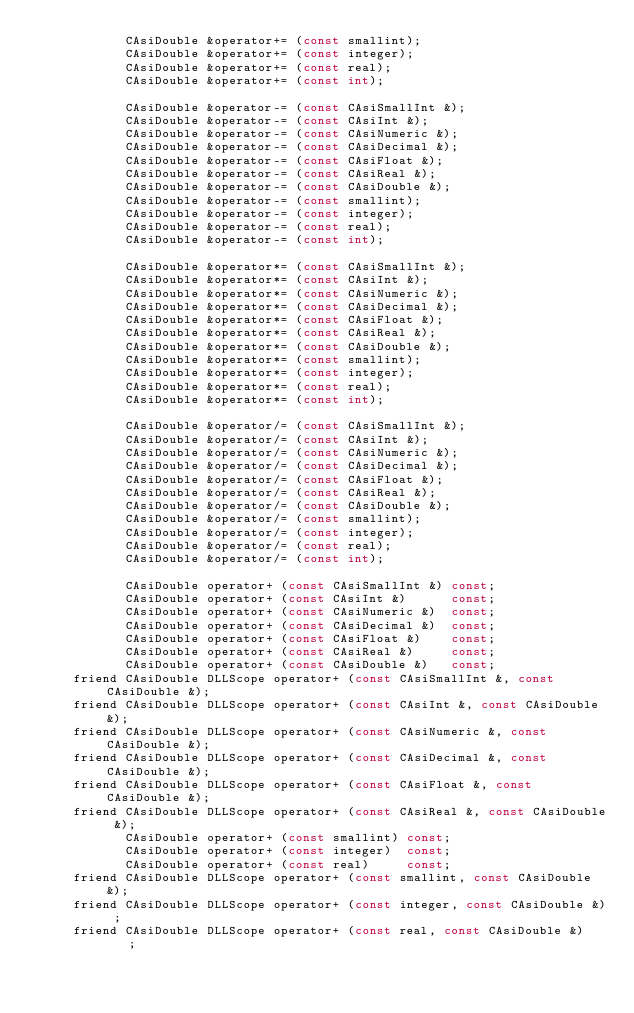Convert code to text. <code><loc_0><loc_0><loc_500><loc_500><_C_>            CAsiDouble &operator+= (const smallint);
            CAsiDouble &operator+= (const integer);
            CAsiDouble &operator+= (const real);
            CAsiDouble &operator+= (const int);

            CAsiDouble &operator-= (const CAsiSmallInt &);
            CAsiDouble &operator-= (const CAsiInt &);
            CAsiDouble &operator-= (const CAsiNumeric &);
            CAsiDouble &operator-= (const CAsiDecimal &);
            CAsiDouble &operator-= (const CAsiFloat &);
            CAsiDouble &operator-= (const CAsiReal &);
            CAsiDouble &operator-= (const CAsiDouble &);
            CAsiDouble &operator-= (const smallint);
            CAsiDouble &operator-= (const integer);
            CAsiDouble &operator-= (const real);
            CAsiDouble &operator-= (const int);

            CAsiDouble &operator*= (const CAsiSmallInt &);
            CAsiDouble &operator*= (const CAsiInt &);
            CAsiDouble &operator*= (const CAsiNumeric &);
            CAsiDouble &operator*= (const CAsiDecimal &);
            CAsiDouble &operator*= (const CAsiFloat &);
            CAsiDouble &operator*= (const CAsiReal &);
            CAsiDouble &operator*= (const CAsiDouble &);
            CAsiDouble &operator*= (const smallint);
            CAsiDouble &operator*= (const integer);
            CAsiDouble &operator*= (const real);
            CAsiDouble &operator*= (const int);

            CAsiDouble &operator/= (const CAsiSmallInt &);
            CAsiDouble &operator/= (const CAsiInt &);
            CAsiDouble &operator/= (const CAsiNumeric &);
            CAsiDouble &operator/= (const CAsiDecimal &);
            CAsiDouble &operator/= (const CAsiFloat &);
            CAsiDouble &operator/= (const CAsiReal &);
            CAsiDouble &operator/= (const CAsiDouble &);
            CAsiDouble &operator/= (const smallint);
            CAsiDouble &operator/= (const integer);
            CAsiDouble &operator/= (const real);
            CAsiDouble &operator/= (const int);

            CAsiDouble operator+ (const CAsiSmallInt &) const;
            CAsiDouble operator+ (const CAsiInt &)      const;
            CAsiDouble operator+ (const CAsiNumeric &)  const;
            CAsiDouble operator+ (const CAsiDecimal &)  const;
            CAsiDouble operator+ (const CAsiFloat &)    const;
            CAsiDouble operator+ (const CAsiReal &)     const;
            CAsiDouble operator+ (const CAsiDouble &)   const;
     friend CAsiDouble DLLScope operator+ (const CAsiSmallInt &, const CAsiDouble &);
     friend CAsiDouble DLLScope operator+ (const CAsiInt &, const CAsiDouble &);
     friend CAsiDouble DLLScope operator+ (const CAsiNumeric &, const CAsiDouble &);
     friend CAsiDouble DLLScope operator+ (const CAsiDecimal &, const CAsiDouble &);
     friend CAsiDouble DLLScope operator+ (const CAsiFloat &, const CAsiDouble &);
     friend CAsiDouble DLLScope operator+ (const CAsiReal &, const CAsiDouble &);
            CAsiDouble operator+ (const smallint) const;
            CAsiDouble operator+ (const integer)  const;
            CAsiDouble operator+ (const real)     const;
     friend CAsiDouble DLLScope operator+ (const smallint, const CAsiDouble &);
     friend CAsiDouble DLLScope operator+ (const integer, const CAsiDouble &) ;
     friend CAsiDouble DLLScope operator+ (const real, const CAsiDouble &)    ;</code> 